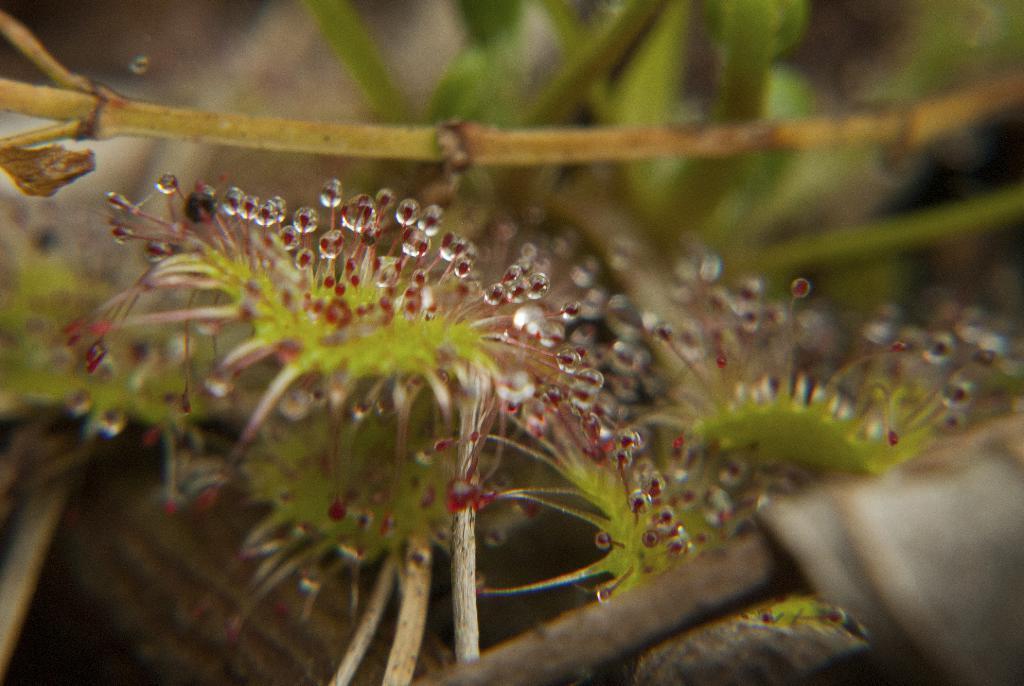In one or two sentences, can you explain what this image depicts? In this image we can see leaves. 